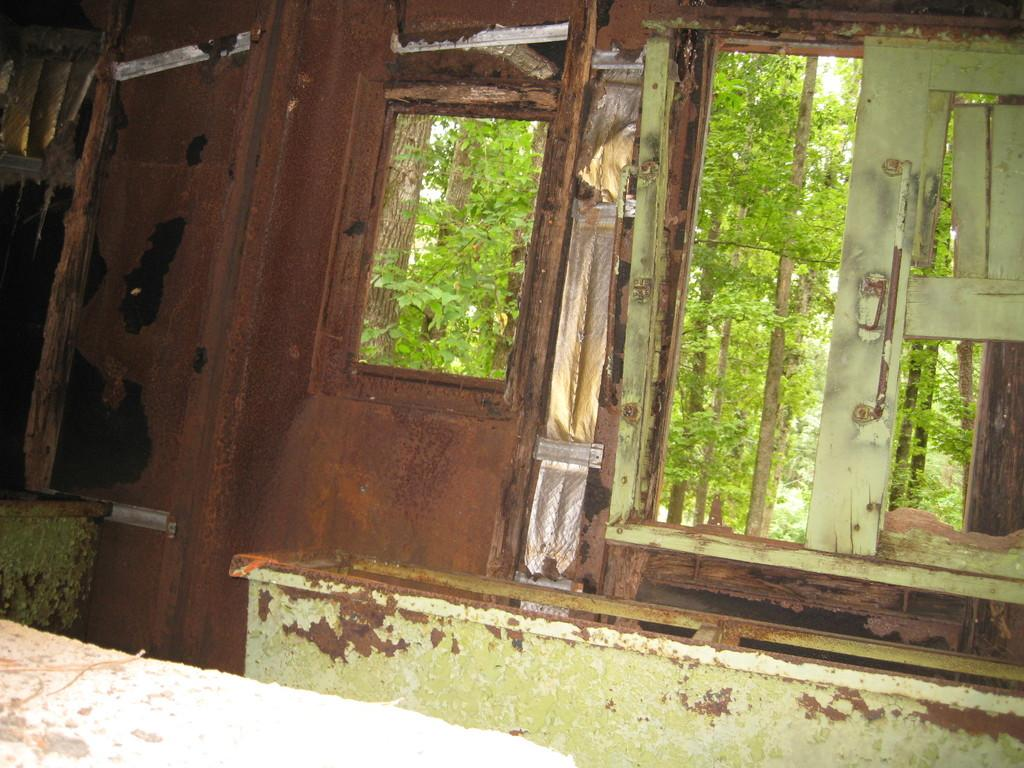What architectural features can be seen in the image? There are windows and doors in the image. What can be seen in the background of the image? There are trees in the background of the image. How many sheep are visible in the image? There are no sheep present in the image. What is the reason for the windows and doors being in the image? The provided facts do not give any information about the reason for the windows and doors being in the image. 